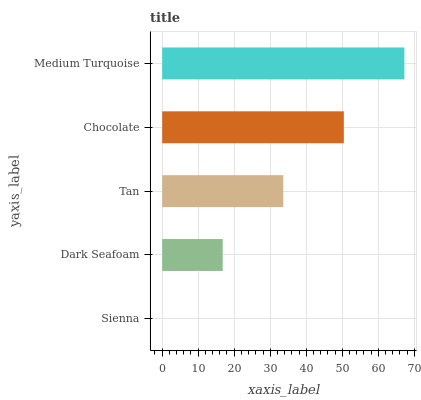Is Sienna the minimum?
Answer yes or no. Yes. Is Medium Turquoise the maximum?
Answer yes or no. Yes. Is Dark Seafoam the minimum?
Answer yes or no. No. Is Dark Seafoam the maximum?
Answer yes or no. No. Is Dark Seafoam greater than Sienna?
Answer yes or no. Yes. Is Sienna less than Dark Seafoam?
Answer yes or no. Yes. Is Sienna greater than Dark Seafoam?
Answer yes or no. No. Is Dark Seafoam less than Sienna?
Answer yes or no. No. Is Tan the high median?
Answer yes or no. Yes. Is Tan the low median?
Answer yes or no. Yes. Is Medium Turquoise the high median?
Answer yes or no. No. Is Dark Seafoam the low median?
Answer yes or no. No. 